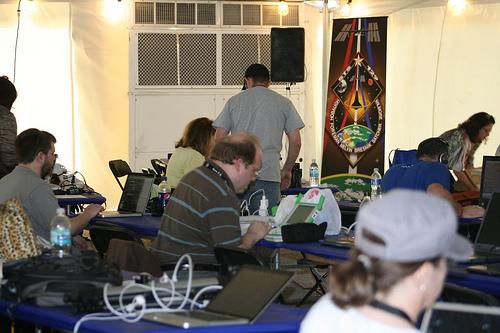How many windows in the room?
Answer briefly. 2. What color is the lady's hat?
Keep it brief. Gray. Is the man in gray on his cell phone?
Give a very brief answer. No. How many water bottles are there?
Concise answer only. 3. Why is only one person not facing the camera?
Answer briefly. Leaving. How many laptops are there?
Keep it brief. 5. 